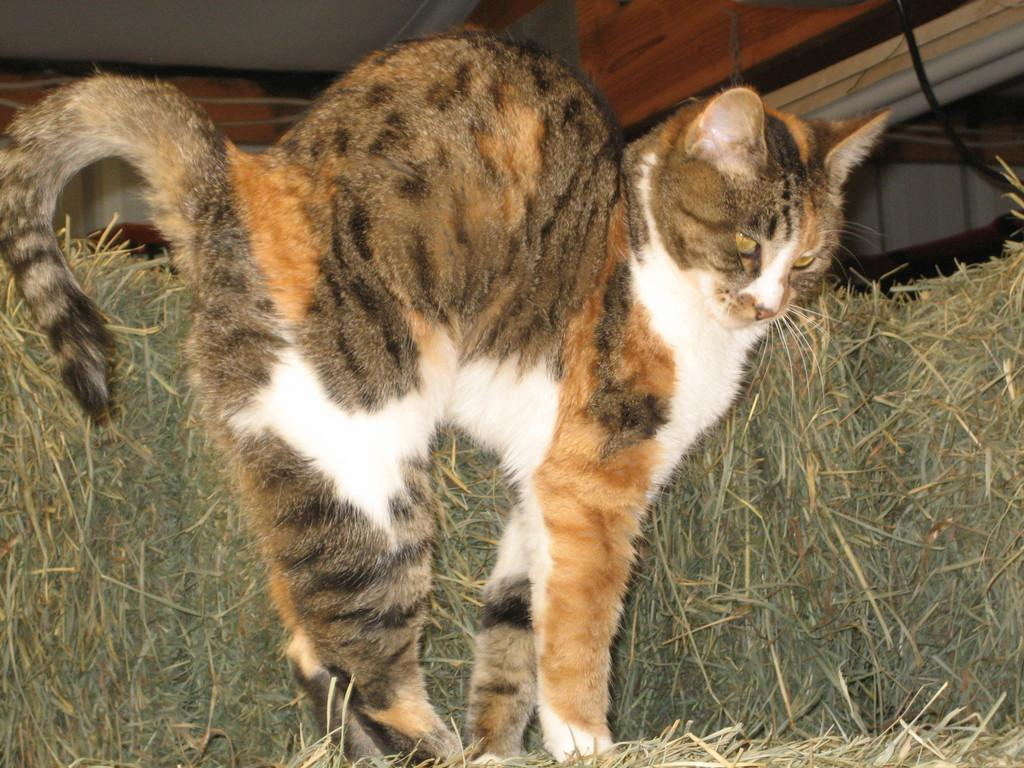What type of animal is in the image? There is a cat in the image. What is the cat doing in the image? The cat is standing. What colors can be seen on the cat? The cat's color is white, cream, and grey. What can be seen in the background of the image? There is grass in the background of the image. What type of event is taking place at the market near the coast in the image? There is no event, market, or coast present in the image; it features a standing cat with a white, cream, and grey coloring and a grassy background. 